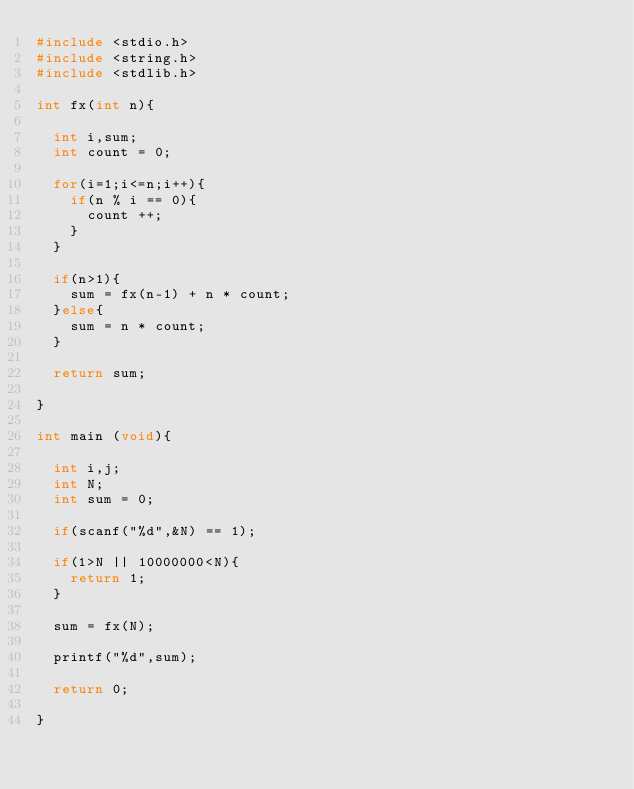<code> <loc_0><loc_0><loc_500><loc_500><_C_>#include <stdio.h>
#include <string.h>
#include <stdlib.h>

int fx(int n){
  
  int i,sum;
  int count = 0;
  
  for(i=1;i<=n;i++){
    if(n % i == 0){
      count ++;
    }
  }
  
  if(n>1){
    sum = fx(n-1) + n * count;
  }else{
    sum = n * count;
  }
  
  return sum;
  
}

int main (void){
  
  int i,j;
  int N;
  int sum = 0;
  
  if(scanf("%d",&N) == 1);
  
  if(1>N || 10000000<N){
    return 1;
  }

  sum = fx(N);
  
  printf("%d",sum);
  
  return 0;

}</code> 